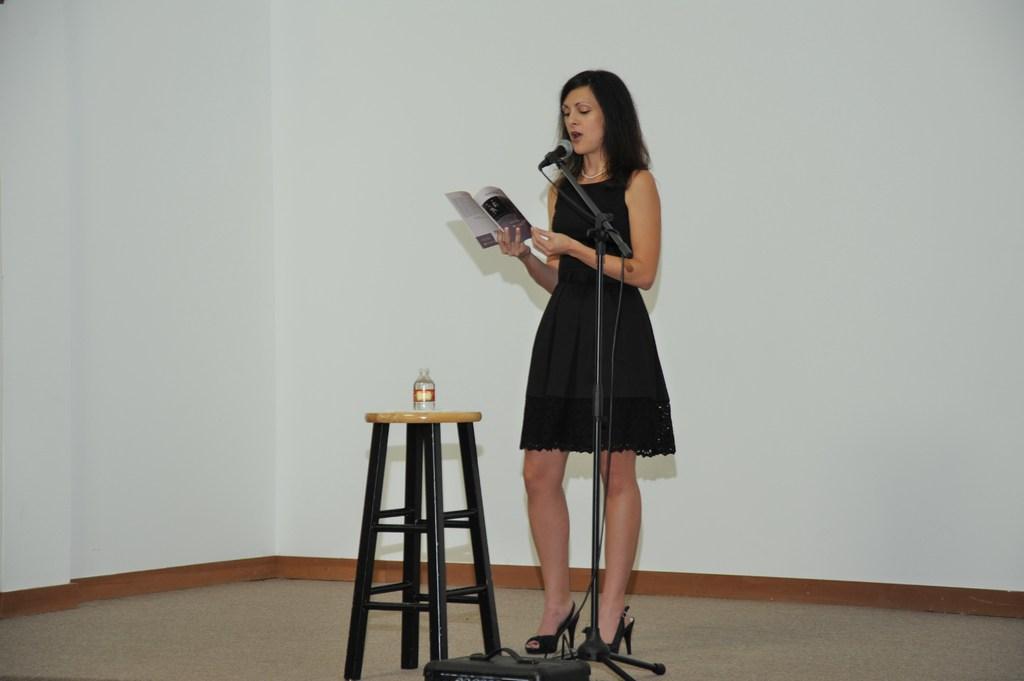Can you describe this image briefly? In this image we can see a woman standing and holding a book, in front of the woman there is a mic, beside the woman there is a stool and a bottle on the table and wall in the background. 